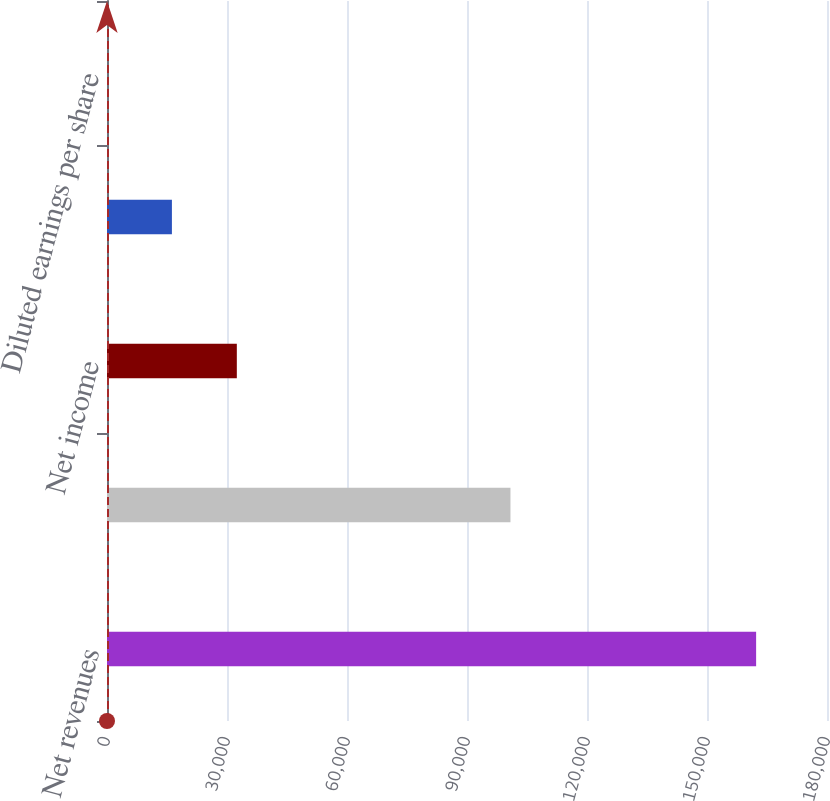Convert chart to OTSL. <chart><loc_0><loc_0><loc_500><loc_500><bar_chart><fcel>Net revenues<fcel>Gross profit<fcel>Net income<fcel>Basic earnings per share<fcel>Diluted earnings per share<nl><fcel>162281<fcel>100866<fcel>32456.5<fcel>16228.4<fcel>0.34<nl></chart> 